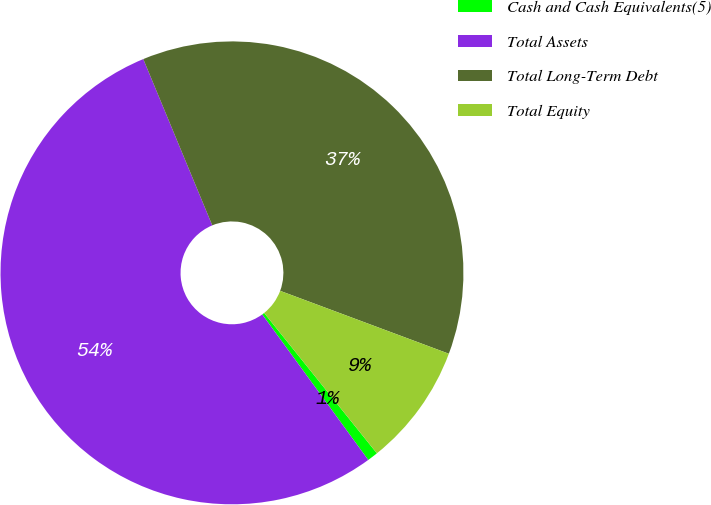Convert chart to OTSL. <chart><loc_0><loc_0><loc_500><loc_500><pie_chart><fcel>Cash and Cash Equivalents(5)<fcel>Total Assets<fcel>Total Long-Term Debt<fcel>Total Equity<nl><fcel>0.75%<fcel>53.76%<fcel>36.94%<fcel>8.55%<nl></chart> 